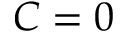<formula> <loc_0><loc_0><loc_500><loc_500>C = 0</formula> 